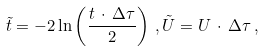Convert formula to latex. <formula><loc_0><loc_0><loc_500><loc_500>\tilde { t } = - 2 \ln \left ( \frac { t \, \cdot \, \Delta \tau } { 2 } \right ) \, , \tilde { U } = U \, \cdot \, \Delta \tau \, ,</formula> 